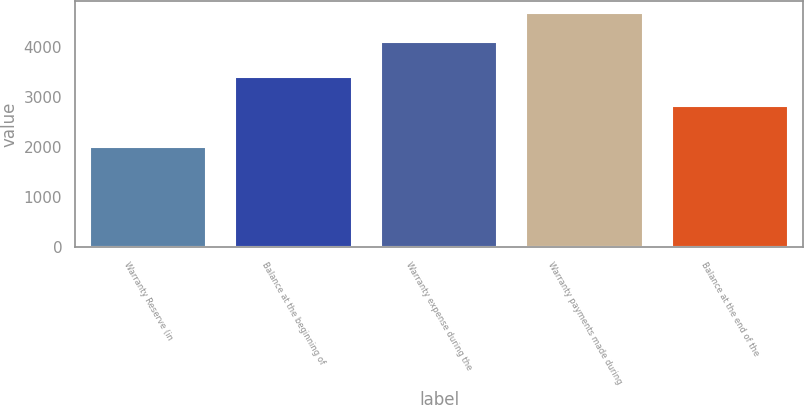Convert chart. <chart><loc_0><loc_0><loc_500><loc_500><bar_chart><fcel>Warranty Reserve (in<fcel>Balance at the beginning of<fcel>Warranty expense during the<fcel>Warranty payments made during<fcel>Balance at the end of the<nl><fcel>2008<fcel>3411<fcel>4094<fcel>4691<fcel>2814<nl></chart> 